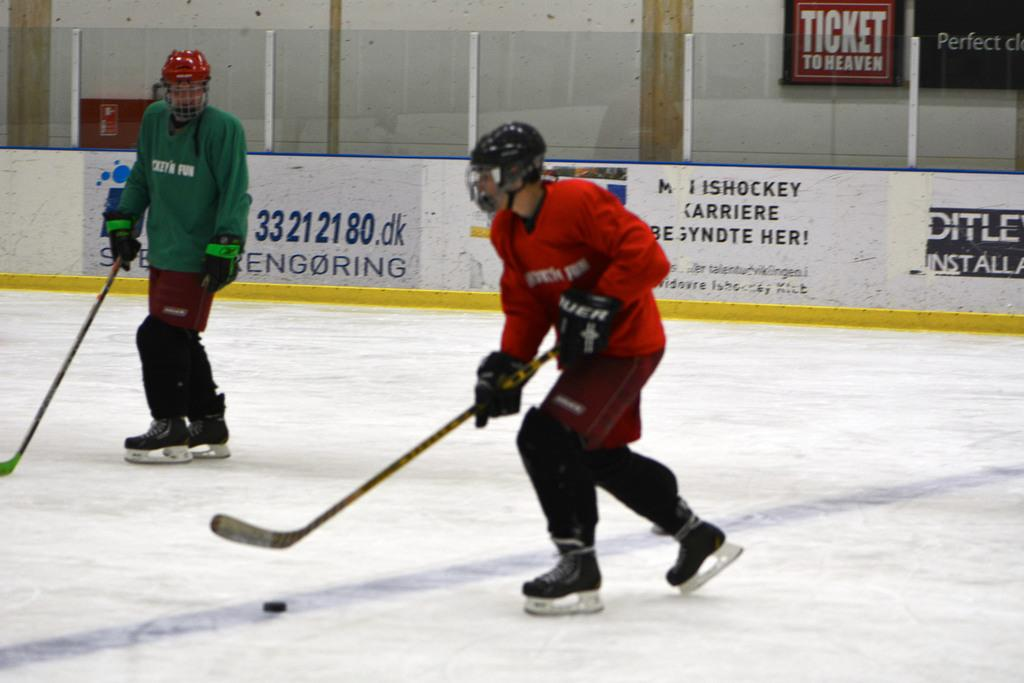<image>
Create a compact narrative representing the image presented. the ice rink has a poster says Ticket to Heaven 